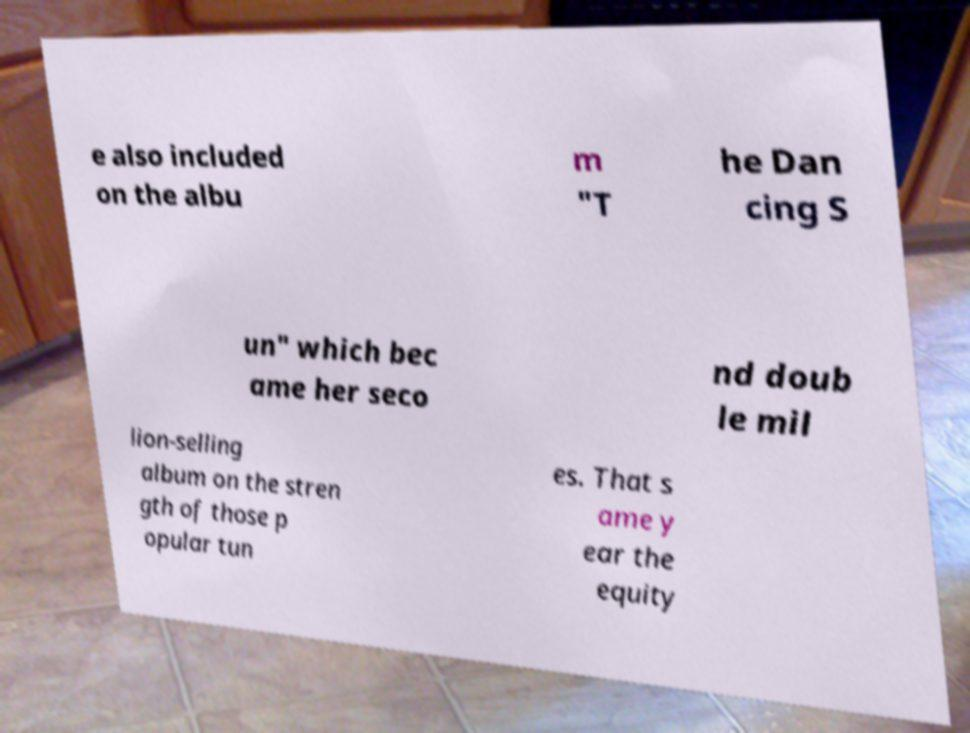There's text embedded in this image that I need extracted. Can you transcribe it verbatim? e also included on the albu m "T he Dan cing S un" which bec ame her seco nd doub le mil lion-selling album on the stren gth of those p opular tun es. That s ame y ear the equity 